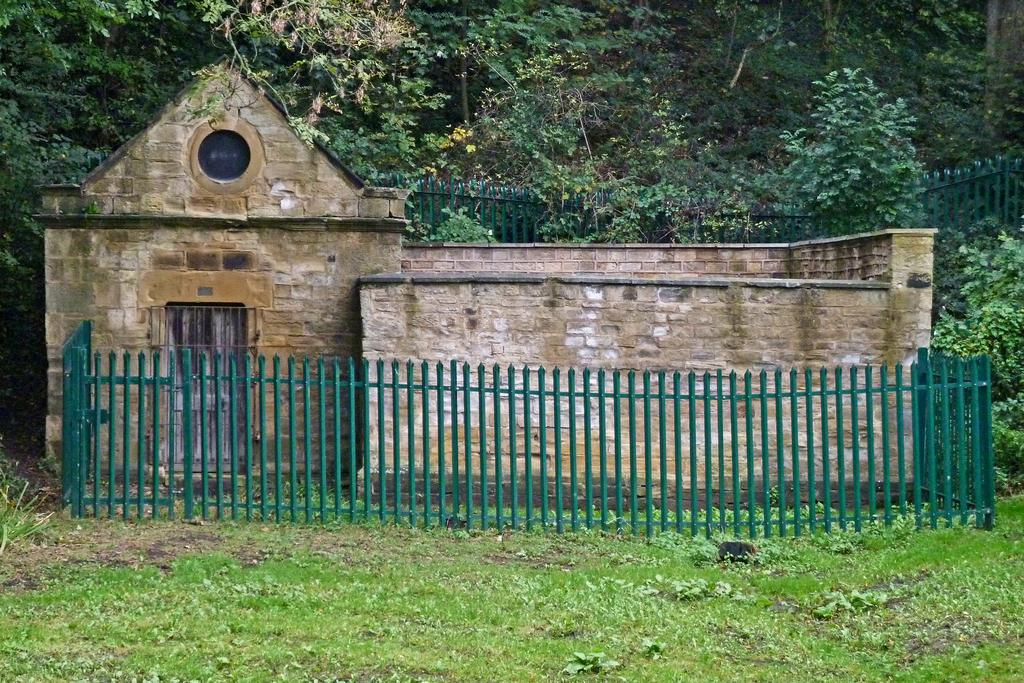What is the main feature of the house in the image? The house has a door. What is located in front of the house? There is a fence in front of the house. What type of vegetation is present in front of the house? Grass is present in front of the house. What can be seen in the background of the image? There is a grill and trees visible in the background. What time of day is the mother discussing government policies in the image? There is no mention of a mother or government policies in the image, so it is not possible to determine the time of day for such a discussion. 